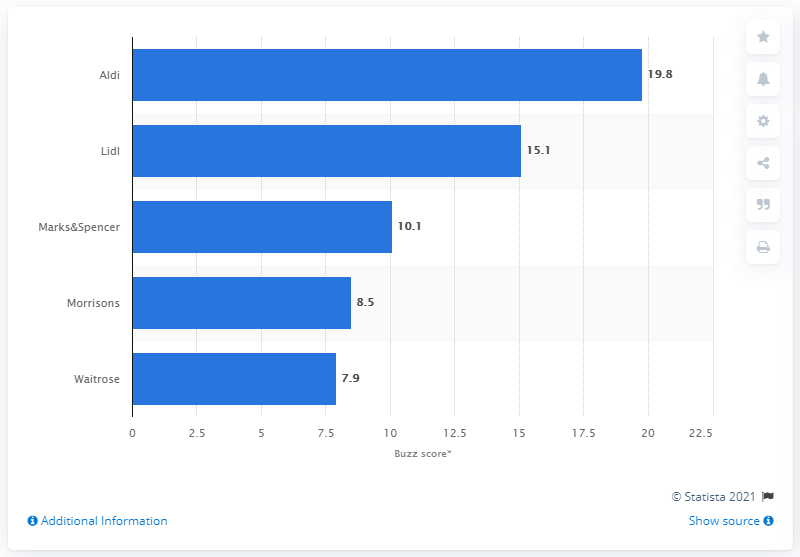Mention a couple of crucial points in this snapshot. In 2019, Aldi was the highest scoring supermarket brand in the UK, according to a recent survey. 